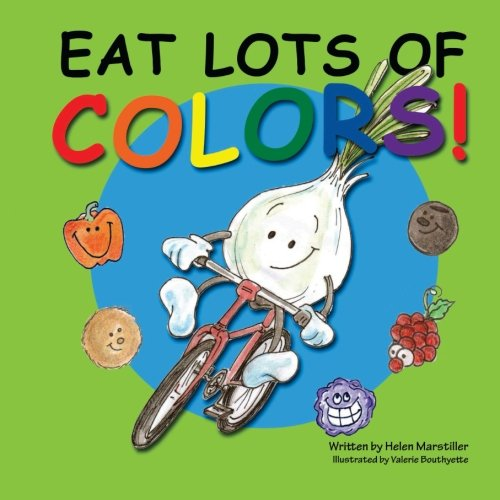Who is the author of this book? The book 'Eat Lots of Colors: A Colorful Look at Healthy Nutrition for Children' is authored by Helen Marstiller, who has crafted an engaging and educational story about eating a diverse range of colorful foods. 